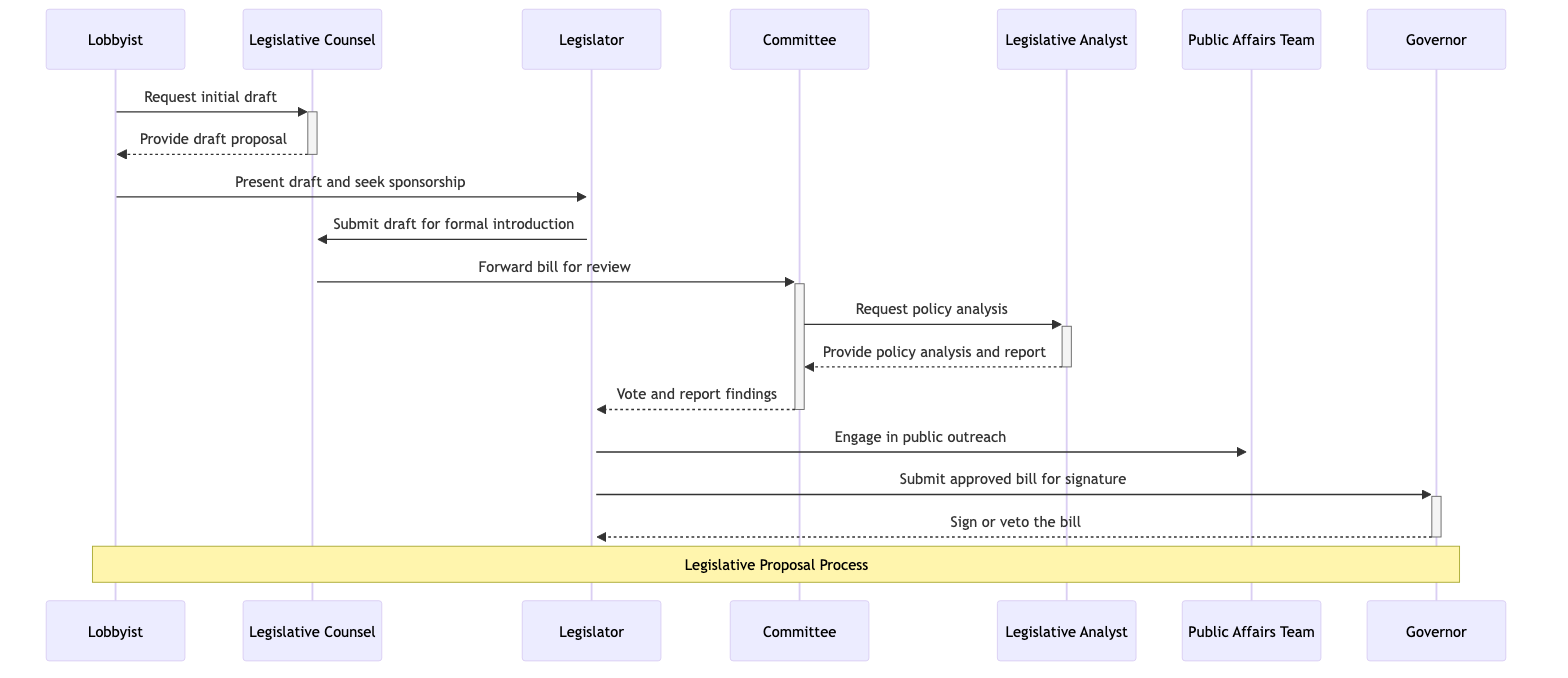What is the role of the Lobbyist? The Lobbyist represents the interests of law enforcement groups, as stated in the actor descriptions of the diagram.
Answer: Represents the interests of law enforcement groups How many actors are involved in the process? There are seven actors involved in the legislative proposal process, which can be counted directly from the actor list in the diagram.
Answer: Seven Who does the Lobbyist present the draft to? The Lobbyist presents the draft to the Legislator, as indicated by the arrow leading from the Lobbyist to the Legislator in the diagram.
Answer: Legislator What does the Committee request from the Legislative Analyst? The Committee requests a policy analysis from the Legislative Analyst, as shown by the message flowing from the Committee to the Legislative Analyst in the diagram.
Answer: Policy analysis What action follows the Legislator's submission of the draft for formal introduction? After the Legislator submits the draft for formal introduction, the Legislative Counsel forwards the bill for review, depicted by the message from the Legislative Counsel to the Committee.
Answer: Forward bill for review What two possible actions can the Governor take on the bill? The Governor can either sign or veto the bill, as indicated by the final message from the Governor to the Legislator in the diagram.
Answer: Sign or veto After the Committee votes, what is reported to the Legislator? After the Committee votes, the findings (approve/amend/reject) are reported to the Legislator, which is represented by the connection from the Committee to the Legislator in the diagram.
Answer: Vote and report findings What is the immediate next step after the Legislative Analyst provides the report? After the Legislative Analyst provides the report, the Committee will vote and report its findings to the Legislator, as outlined in the flow of messages in the diagram.
Answer: Vote and report findings Which role is responsible for conducting public outreach and advocacy? The Public Affairs Team is responsible for conducting public outreach and advocacy, as defined in the role descriptions in the diagram.
Answer: Public Affairs Team 